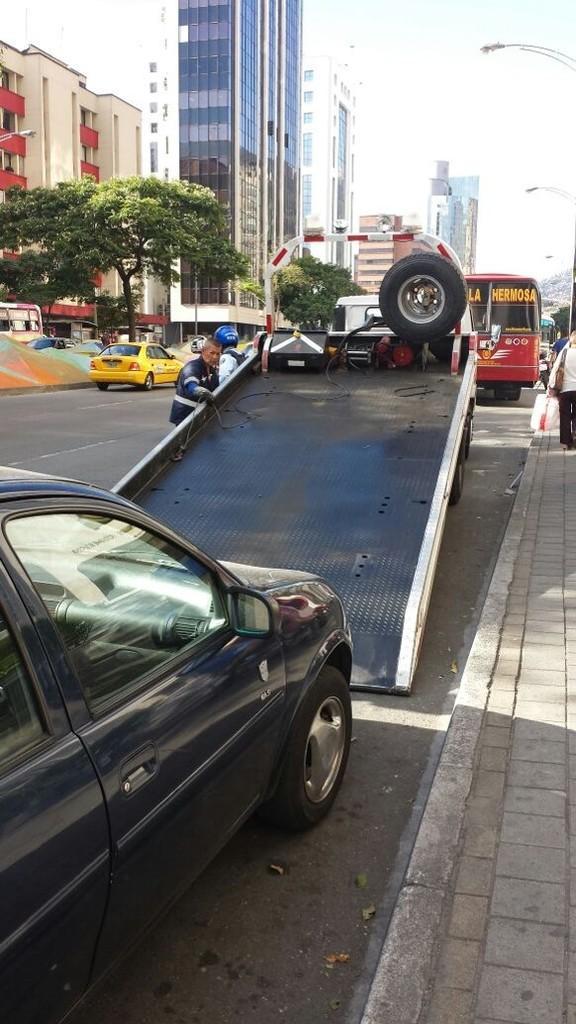Can you describe this image briefly? In this picture we have vehicles on the road and a car being towed onto a truck. In the background we have many buildings and trees. 